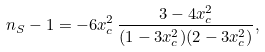<formula> <loc_0><loc_0><loc_500><loc_500>n _ { S } - 1 = - 6 x _ { c } ^ { 2 } \, \frac { 3 - 4 x _ { c } ^ { 2 } } { ( 1 - 3 x _ { c } ^ { 2 } ) ( 2 - 3 x _ { c } ^ { 2 } ) } ,</formula> 